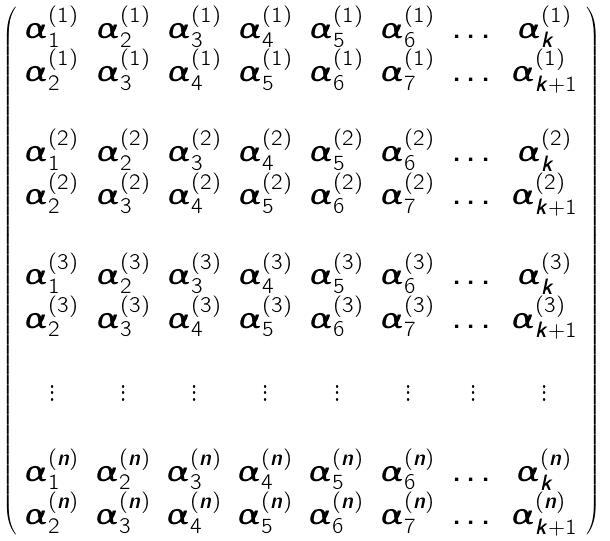<formula> <loc_0><loc_0><loc_500><loc_500>\left ( \begin{array} { c c c c c c c c } \alpha _ { 1 } ^ { ( 1 ) } & \alpha _ { 2 } ^ { ( 1 ) } & \alpha _ { 3 } ^ { ( 1 ) } & \alpha _ { 4 } ^ { ( 1 ) } & \alpha _ { 5 } ^ { ( 1 ) } & \alpha _ { 6 } ^ { ( 1 ) } & \dots & \alpha _ { k } ^ { ( 1 ) } \\ \alpha _ { 2 } ^ { ( 1 ) } & \alpha _ { 3 } ^ { ( 1 ) } & \alpha _ { 4 } ^ { ( 1 ) } & \alpha _ { 5 } ^ { ( 1 ) } & \alpha _ { 6 } ^ { ( 1 ) } & \alpha _ { 7 } ^ { ( 1 ) } & \dots & \alpha _ { k + 1 } ^ { ( 1 ) } \\ \\ \alpha _ { 1 } ^ { ( 2 ) } & \alpha _ { 2 } ^ { ( 2 ) } & \alpha _ { 3 } ^ { ( 2 ) } & \alpha _ { 4 } ^ { ( 2 ) } & \alpha _ { 5 } ^ { ( 2 ) } & \alpha _ { 6 } ^ { ( 2 ) } & \dots & \alpha _ { k } ^ { ( 2 ) } \\ \alpha _ { 2 } ^ { ( 2 ) } & \alpha _ { 3 } ^ { ( 2 ) } & \alpha _ { 4 } ^ { ( 2 ) } & \alpha _ { 5 } ^ { ( 2 ) } & \alpha _ { 6 } ^ { ( 2 ) } & \alpha _ { 7 } ^ { ( 2 ) } & \dots & \alpha _ { k + 1 } ^ { ( 2 ) } \\ \\ \alpha _ { 1 } ^ { ( 3 ) } & \alpha _ { 2 } ^ { ( 3 ) } & \alpha _ { 3 } ^ { ( 3 ) } & \alpha _ { 4 } ^ { ( 3 ) } & \alpha _ { 5 } ^ { ( 3 ) } & \alpha _ { 6 } ^ { ( 3 ) } & \dots & \alpha _ { k } ^ { ( 3 ) } \\ \alpha _ { 2 } ^ { ( 3 ) } & \alpha _ { 3 } ^ { ( 3 ) } & \alpha _ { 4 } ^ { ( 3 ) } & \alpha _ { 5 } ^ { ( 3 ) } & \alpha _ { 6 } ^ { ( 3 ) } & \alpha _ { 7 } ^ { ( 3 ) } & \dots & \alpha _ { k + 1 } ^ { ( 3 ) } \\ \\ \vdots & \vdots & \vdots & \vdots & \vdots & \vdots & \vdots & \vdots \\ \\ \alpha _ { 1 } ^ { ( n ) } & \alpha _ { 2 } ^ { ( n ) } & \alpha _ { 3 } ^ { ( n ) } & \alpha _ { 4 } ^ { ( n ) } & \alpha _ { 5 } ^ { ( n ) } & \alpha _ { 6 } ^ { ( n ) } & \dots & \alpha _ { k } ^ { ( n ) } \\ \alpha _ { 2 } ^ { ( n ) } & \alpha _ { 3 } ^ { ( n ) } & \alpha _ { 4 } ^ { ( n ) } & \alpha _ { 5 } ^ { ( n ) } & \alpha _ { 6 } ^ { ( n ) } & \alpha _ { 7 } ^ { ( n ) } & \dots & \alpha _ { k + 1 } ^ { ( n ) } \\ \end{array} \right )</formula> 